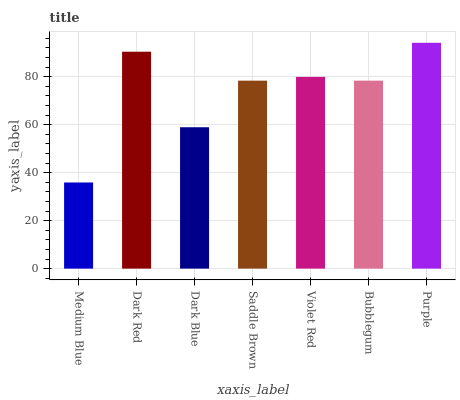Is Dark Red the minimum?
Answer yes or no. No. Is Dark Red the maximum?
Answer yes or no. No. Is Dark Red greater than Medium Blue?
Answer yes or no. Yes. Is Medium Blue less than Dark Red?
Answer yes or no. Yes. Is Medium Blue greater than Dark Red?
Answer yes or no. No. Is Dark Red less than Medium Blue?
Answer yes or no. No. Is Saddle Brown the high median?
Answer yes or no. Yes. Is Saddle Brown the low median?
Answer yes or no. Yes. Is Purple the high median?
Answer yes or no. No. Is Dark Blue the low median?
Answer yes or no. No. 